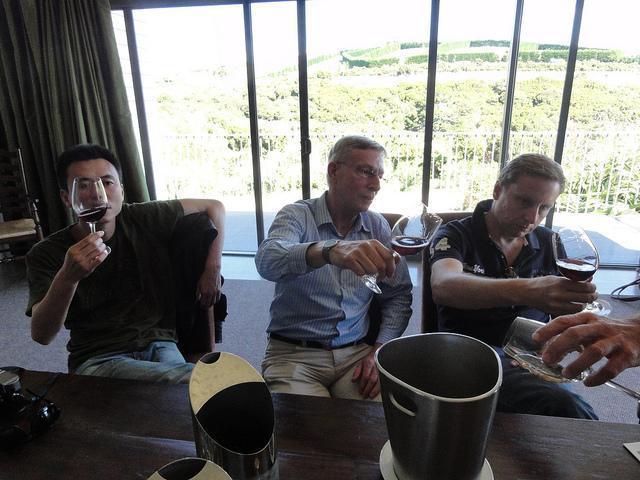How many glasses of wine are in the photo?
Give a very brief answer. 3. How many faces are in the photo?
Give a very brief answer. 3. How many chairs are there?
Give a very brief answer. 2. How many dining tables are in the photo?
Give a very brief answer. 2. How many people are there?
Give a very brief answer. 4. How many wine glasses are in the photo?
Give a very brief answer. 3. 